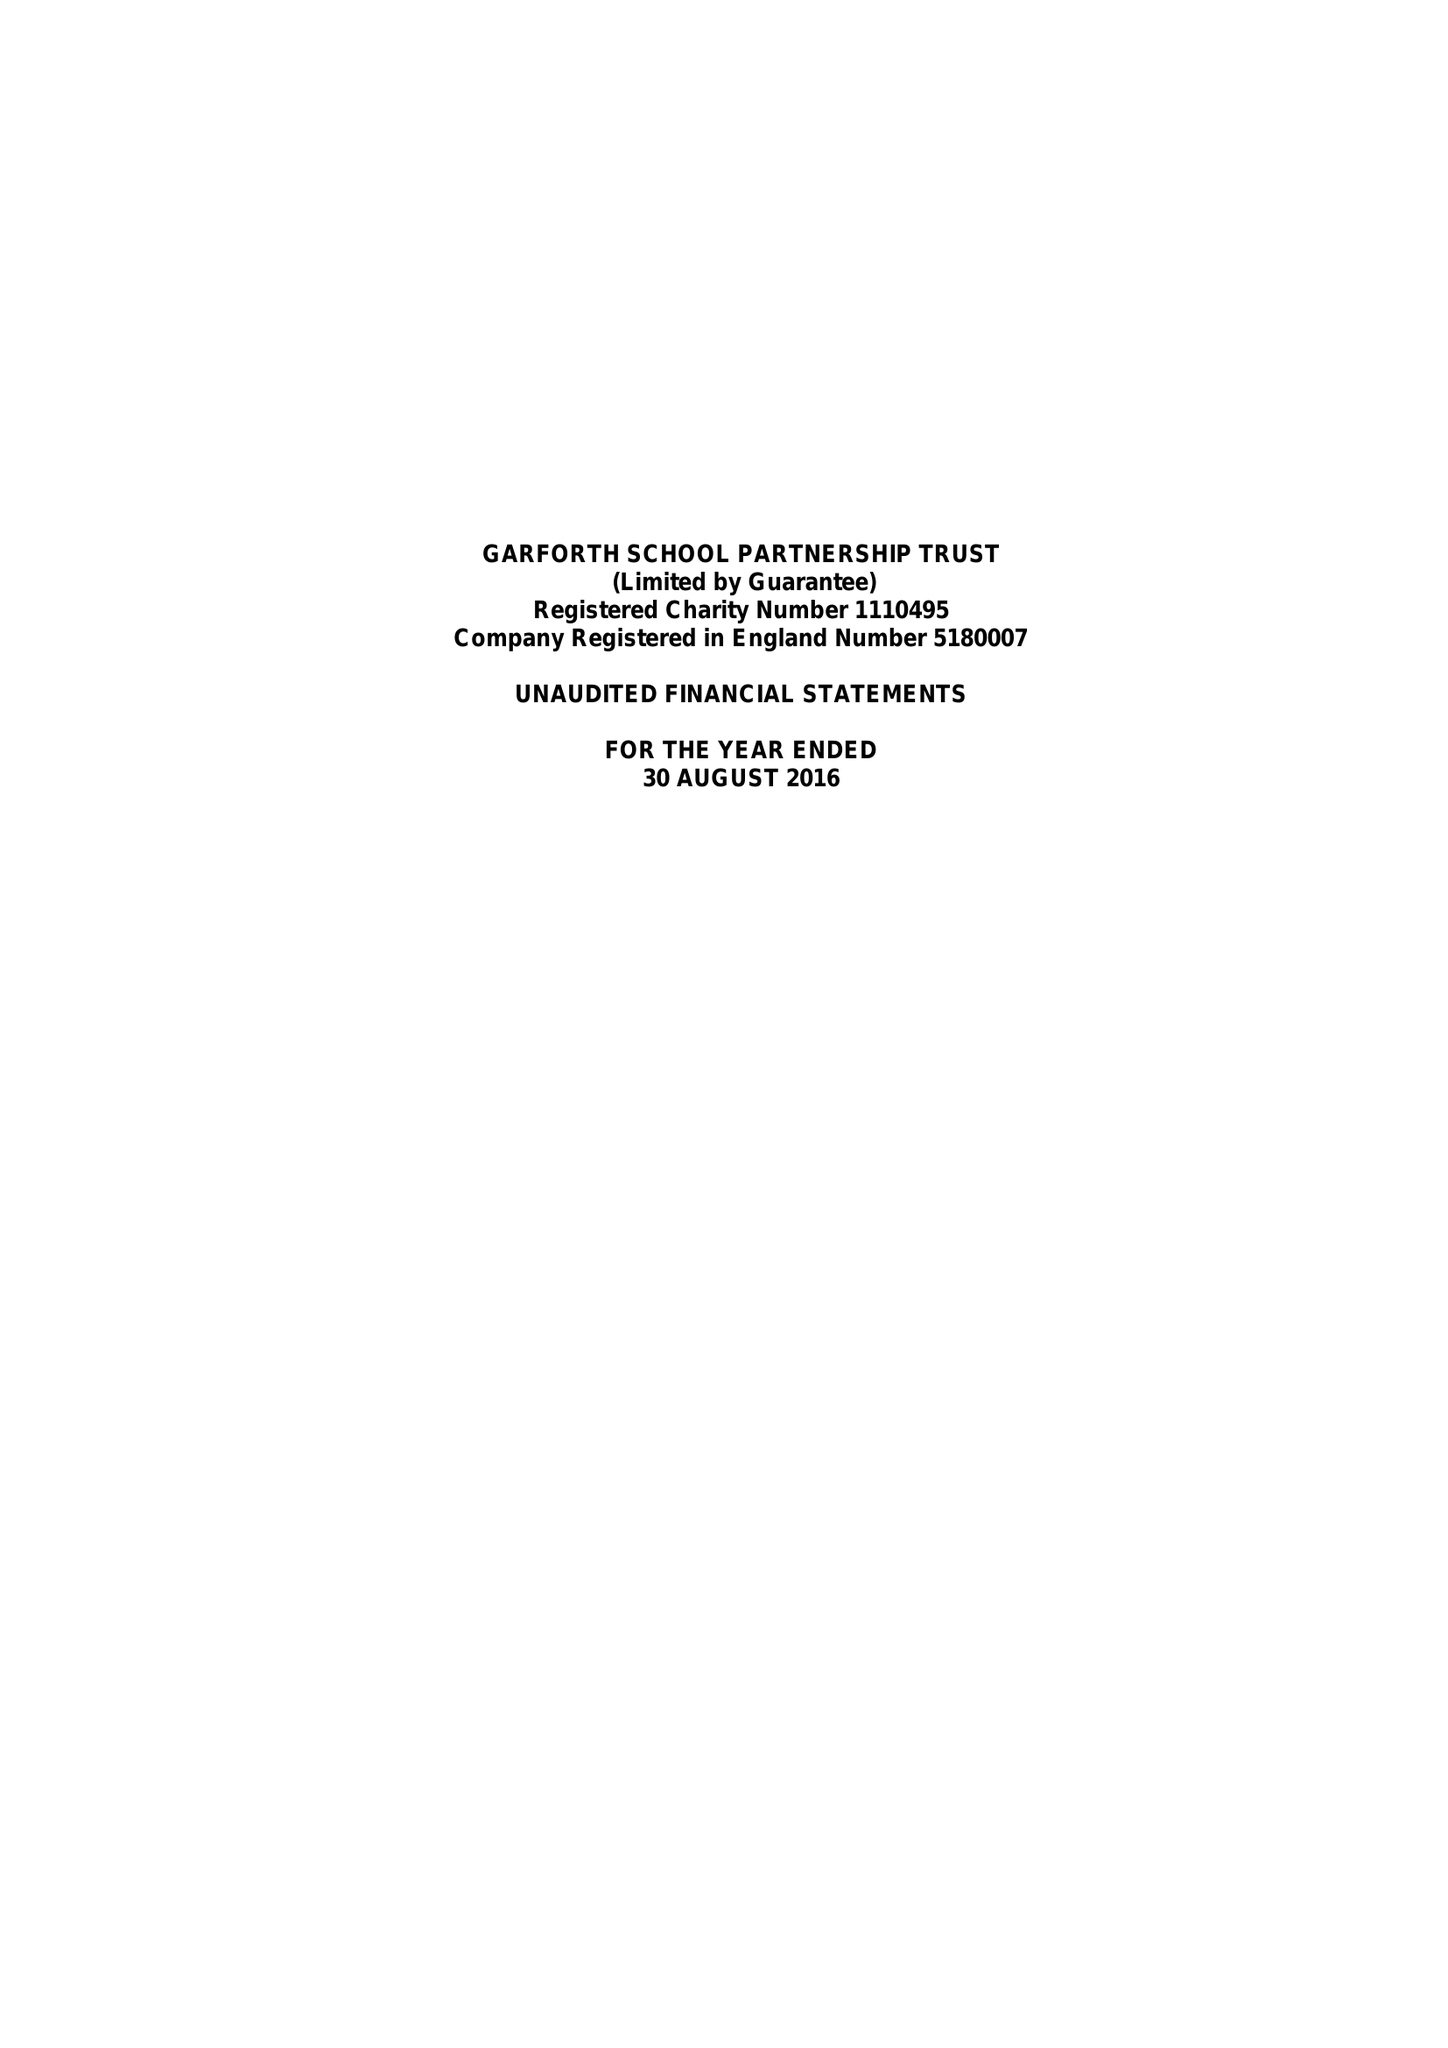What is the value for the income_annually_in_british_pounds?
Answer the question using a single word or phrase. 37090.00 